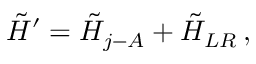Convert formula to latex. <formula><loc_0><loc_0><loc_500><loc_500>\tilde { H } ^ { \prime } = \tilde { H } _ { j - A } + \tilde { H } _ { L R } \, ,</formula> 